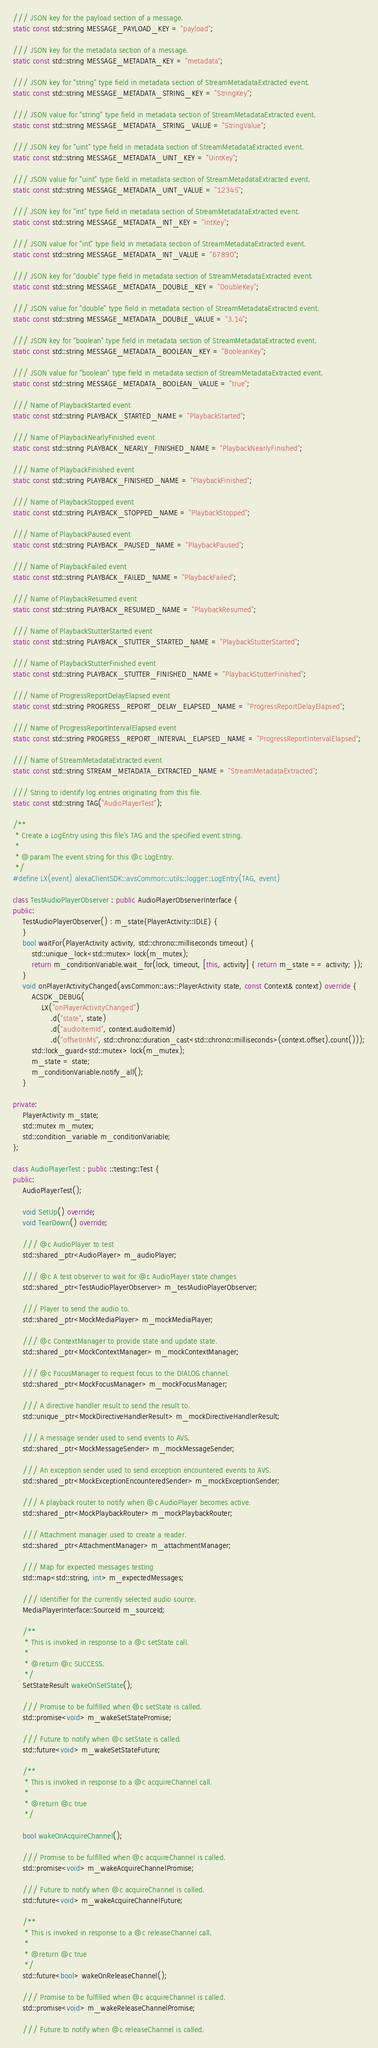<code> <loc_0><loc_0><loc_500><loc_500><_C++_>
/// JSON key for the payload section of a message.
static const std::string MESSAGE_PAYLOAD_KEY = "payload";

/// JSON key for the metadata section of a message.
static const std::string MESSAGE_METADATA_KEY = "metadata";

/// JSON key for "string" type field in metadata section of StreamMetadataExtracted event.
static const std::string MESSAGE_METADATA_STRING_KEY = "StringKey";

/// JSON value for "string" type field in metadata section of StreamMetadataExtracted event.
static const std::string MESSAGE_METADATA_STRING_VALUE = "StringValue";

/// JSON key for "uint" type field in metadata section of StreamMetadataExtracted event.
static const std::string MESSAGE_METADATA_UINT_KEY = "UintKey";

/// JSON value for "uint" type field in metadata section of StreamMetadataExtracted event.
static const std::string MESSAGE_METADATA_UINT_VALUE = "12345";

/// JSON key for "int" type field in metadata section of StreamMetadataExtracted event.
static const std::string MESSAGE_METADATA_INT_KEY = "IntKey";

/// JSON value for "int" type field in metadata section of StreamMetadataExtracted event.
static const std::string MESSAGE_METADATA_INT_VALUE = "67890";

/// JSON key for "double" type field in metadata section of StreamMetadataExtracted event.
static const std::string MESSAGE_METADATA_DOUBLE_KEY = "DoubleKey";

/// JSON value for "double" type field in metadata section of StreamMetadataExtracted event.
static const std::string MESSAGE_METADATA_DOUBLE_VALUE = "3.14";

/// JSON key for "boolean" type field in metadata section of StreamMetadataExtracted event.
static const std::string MESSAGE_METADATA_BOOLEAN_KEY = "BooleanKey";

/// JSON value for "boolean" type field in metadata section of StreamMetadataExtracted event.
static const std::string MESSAGE_METADATA_BOOLEAN_VALUE = "true";

/// Name of PlaybackStarted event
static const std::string PLAYBACK_STARTED_NAME = "PlaybackStarted";

/// Name of PlaybackNearlyFinished event
static const std::string PLAYBACK_NEARLY_FINISHED_NAME = "PlaybackNearlyFinished";

/// Name of PlaybackFinished event
static const std::string PLAYBACK_FINISHED_NAME = "PlaybackFinished";

/// Name of PlaybackStopped event
static const std::string PLAYBACK_STOPPED_NAME = "PlaybackStopped";

/// Name of PlaybackPaused event
static const std::string PLAYBACK_PAUSED_NAME = "PlaybackPaused";

/// Name of PlaybackFailed event
static const std::string PLAYBACK_FAILED_NAME = "PlaybackFailed";

/// Name of PlaybackResumed event
static const std::string PLAYBACK_RESUMED_NAME = "PlaybackResumed";

/// Name of PlaybackStutterStarted event
static const std::string PLAYBACK_STUTTER_STARTED_NAME = "PlaybackStutterStarted";

/// Name of PlaybackStutterFinished event
static const std::string PLAYBACK_STUTTER_FINISHED_NAME = "PlaybackStutterFinished";

/// Name of ProgressReportDelayElapsed event
static const std::string PROGRESS_REPORT_DELAY_ELAPSED_NAME = "ProgressReportDelayElapsed";

/// Name of ProgressReportIntervalElapsed event
static const std::string PROGRESS_REPORT_INTERVAL_ELAPSED_NAME = "ProgressReportIntervalElapsed";

/// Name of StreamMetadataExtracted event
static const std::string STREAM_METADATA_EXTRACTED_NAME = "StreamMetadataExtracted";

/// String to identify log entries originating from this file.
static const std::string TAG("AudioPlayerTest");

/**
 * Create a LogEntry using this file's TAG and the specified event string.
 *
 * @param The event string for this @c LogEntry.
 */
#define LX(event) alexaClientSDK::avsCommon::utils::logger::LogEntry(TAG, event)

class TestAudioPlayerObserver : public AudioPlayerObserverInterface {
public:
    TestAudioPlayerObserver() : m_state{PlayerActivity::IDLE} {
    }
    bool waitFor(PlayerActivity activity, std::chrono::milliseconds timeout) {
        std::unique_lock<std::mutex> lock(m_mutex);
        return m_conditionVariable.wait_for(lock, timeout, [this, activity] { return m_state == activity; });
    }
    void onPlayerActivityChanged(avsCommon::avs::PlayerActivity state, const Context& context) override {
        ACSDK_DEBUG(
            LX("onPlayerActivityChanged")
                .d("state", state)
                .d("audioItemId", context.audioItemId)
                .d("offsetInMs", std::chrono::duration_cast<std::chrono::milliseconds>(context.offset).count()));
        std::lock_guard<std::mutex> lock(m_mutex);
        m_state = state;
        m_conditionVariable.notify_all();
    }

private:
    PlayerActivity m_state;
    std::mutex m_mutex;
    std::condition_variable m_conditionVariable;
};

class AudioPlayerTest : public ::testing::Test {
public:
    AudioPlayerTest();

    void SetUp() override;
    void TearDown() override;

    /// @c AudioPlayer to test
    std::shared_ptr<AudioPlayer> m_audioPlayer;

    /// @c A test observer to wait for @c AudioPlayer state changes
    std::shared_ptr<TestAudioPlayerObserver> m_testAudioPlayerObserver;

    /// Player to send the audio to.
    std::shared_ptr<MockMediaPlayer> m_mockMediaPlayer;

    /// @c ContextManager to provide state and update state.
    std::shared_ptr<MockContextManager> m_mockContextManager;

    /// @c FocusManager to request focus to the DIALOG channel.
    std::shared_ptr<MockFocusManager> m_mockFocusManager;

    /// A directive handler result to send the result to.
    std::unique_ptr<MockDirectiveHandlerResult> m_mockDirectiveHandlerResult;

    /// A message sender used to send events to AVS.
    std::shared_ptr<MockMessageSender> m_mockMessageSender;

    /// An exception sender used to send exception encountered events to AVS.
    std::shared_ptr<MockExceptionEncounteredSender> m_mockExceptionSender;

    /// A playback router to notify when @c AudioPlayer becomes active.
    std::shared_ptr<MockPlaybackRouter> m_mockPlaybackRouter;

    /// Attachment manager used to create a reader.
    std::shared_ptr<AttachmentManager> m_attachmentManager;

    /// Map for expected messages testing
    std::map<std::string, int> m_expectedMessages;

    /// Identifier for the currently selected audio source.
    MediaPlayerInterface::SourceId m_sourceId;

    /**
     * This is invoked in response to a @c setState call.
     *
     * @return @c SUCCESS.
     */
    SetStateResult wakeOnSetState();

    /// Promise to be fulfilled when @c setState is called.
    std::promise<void> m_wakeSetStatePromise;

    /// Future to notify when @c setState is called.
    std::future<void> m_wakeSetStateFuture;

    /**
     * This is invoked in response to a @c acquireChannel call.
     *
     * @return @c true
     */

    bool wakeOnAcquireChannel();

    /// Promise to be fulfilled when @c acquireChannel is called.
    std::promise<void> m_wakeAcquireChannelPromise;

    /// Future to notify when @c acquireChannel is called.
    std::future<void> m_wakeAcquireChannelFuture;

    /**
     * This is invoked in response to a @c releaseChannel call.
     *
     * @return @c true
     */
    std::future<bool> wakeOnReleaseChannel();

    /// Promise to be fulfilled when @c acquireChannel is called.
    std::promise<void> m_wakeReleaseChannelPromise;

    /// Future to notify when @c releaseChannel is called.</code> 